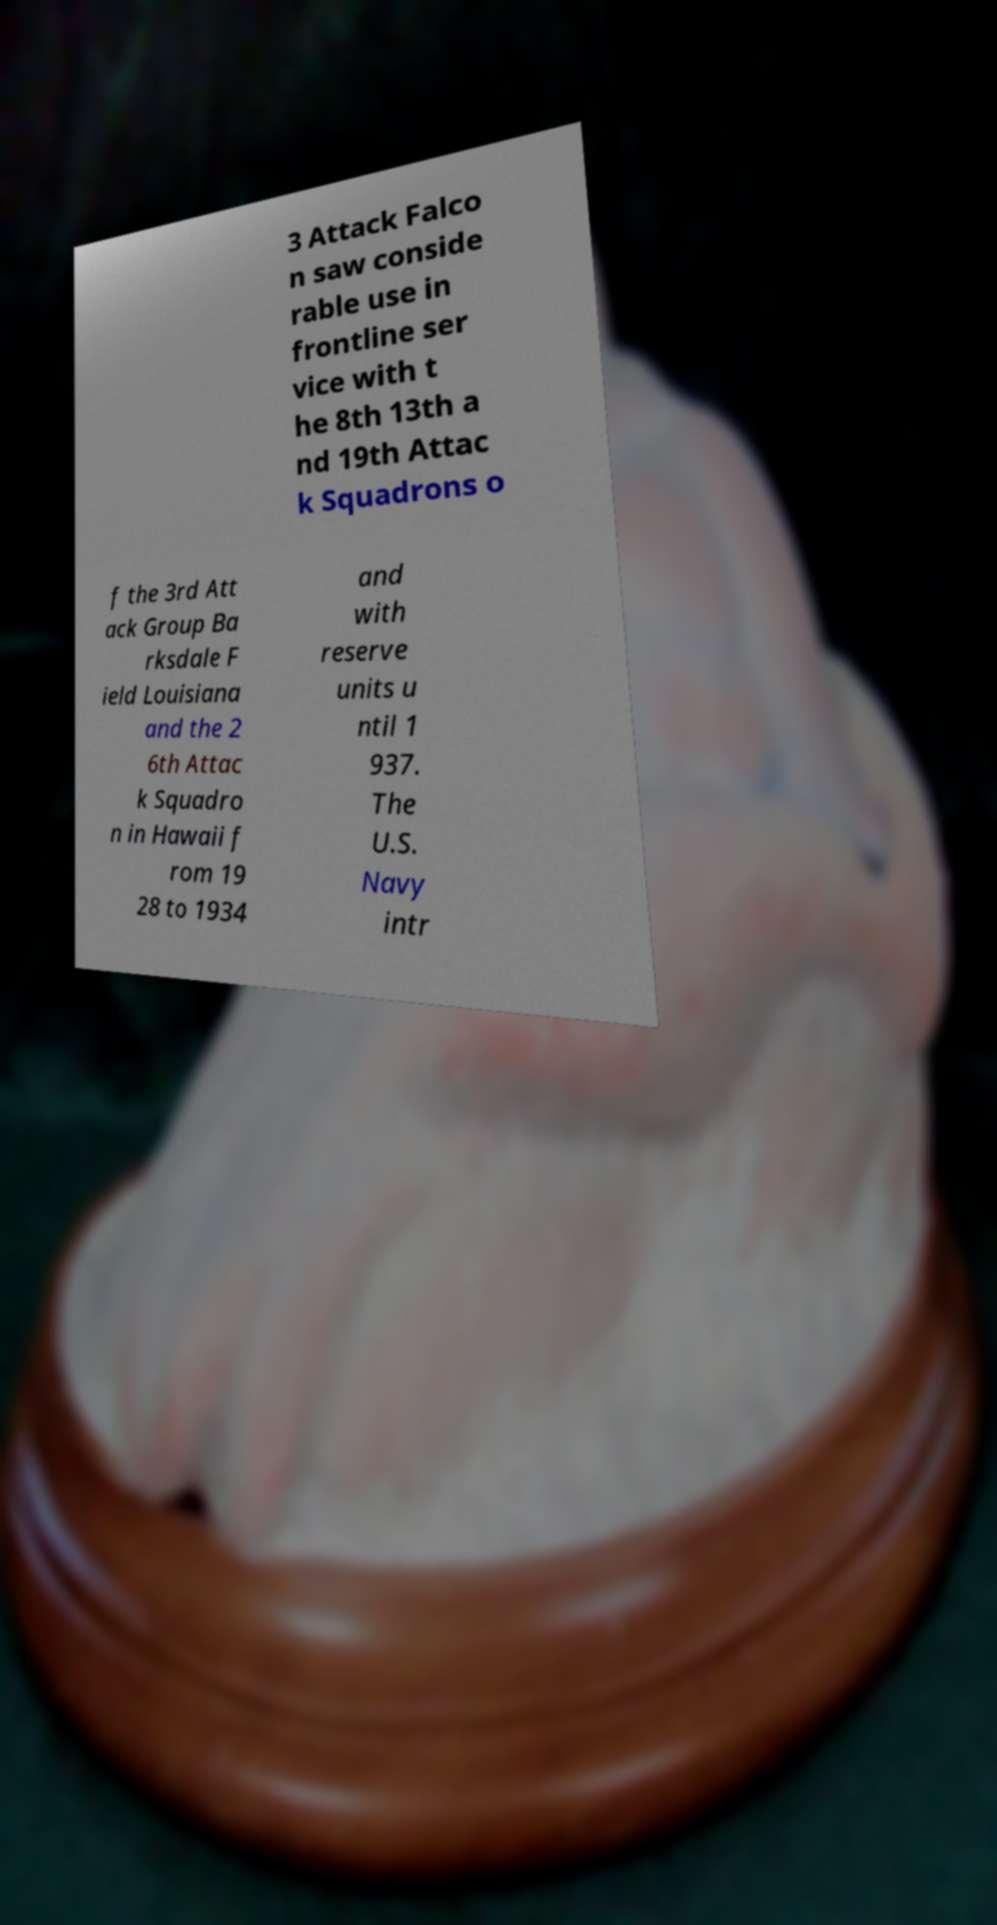Please read and relay the text visible in this image. What does it say? 3 Attack Falco n saw conside rable use in frontline ser vice with t he 8th 13th a nd 19th Attac k Squadrons o f the 3rd Att ack Group Ba rksdale F ield Louisiana and the 2 6th Attac k Squadro n in Hawaii f rom 19 28 to 1934 and with reserve units u ntil 1 937. The U.S. Navy intr 